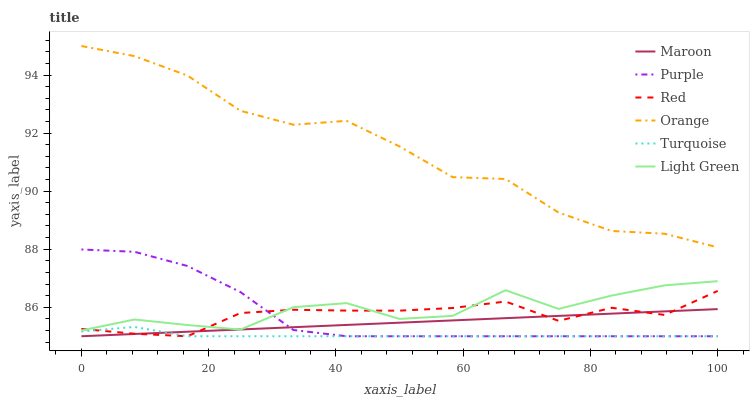Does Purple have the minimum area under the curve?
Answer yes or no. No. Does Purple have the maximum area under the curve?
Answer yes or no. No. Is Purple the smoothest?
Answer yes or no. No. Is Purple the roughest?
Answer yes or no. No. Does Light Green have the lowest value?
Answer yes or no. No. Does Purple have the highest value?
Answer yes or no. No. Is Purple less than Orange?
Answer yes or no. Yes. Is Orange greater than Turquoise?
Answer yes or no. Yes. Does Purple intersect Orange?
Answer yes or no. No. 